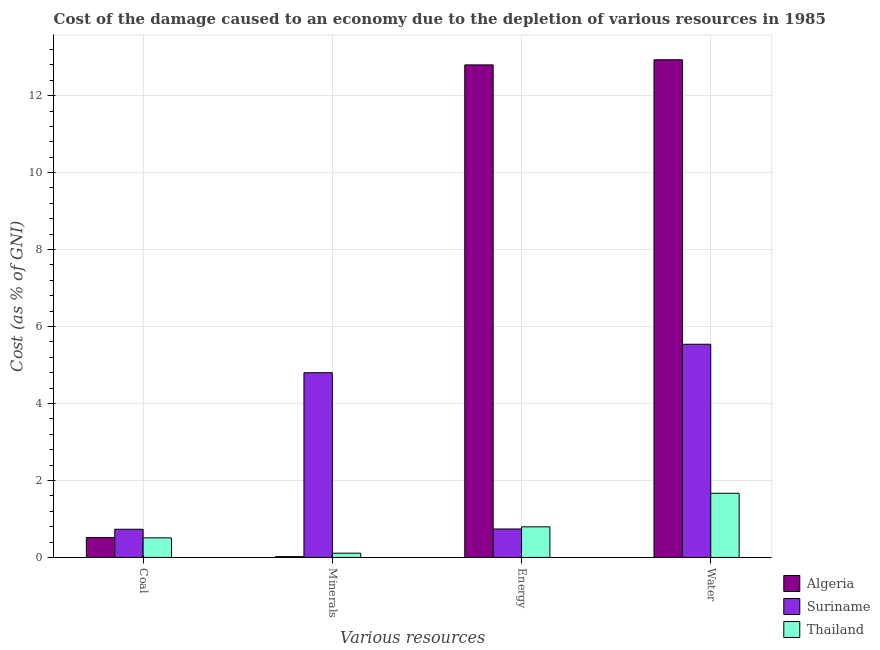How many different coloured bars are there?
Make the answer very short. 3. How many bars are there on the 4th tick from the left?
Your answer should be very brief. 3. How many bars are there on the 3rd tick from the right?
Your answer should be compact. 3. What is the label of the 3rd group of bars from the left?
Provide a short and direct response. Energy. What is the cost of damage due to depletion of water in Suriname?
Your answer should be compact. 5.54. Across all countries, what is the maximum cost of damage due to depletion of energy?
Make the answer very short. 12.8. Across all countries, what is the minimum cost of damage due to depletion of water?
Offer a terse response. 1.67. In which country was the cost of damage due to depletion of energy maximum?
Provide a succinct answer. Algeria. In which country was the cost of damage due to depletion of energy minimum?
Your response must be concise. Suriname. What is the total cost of damage due to depletion of minerals in the graph?
Your answer should be very brief. 4.93. What is the difference between the cost of damage due to depletion of minerals in Algeria and that in Thailand?
Make the answer very short. -0.09. What is the difference between the cost of damage due to depletion of minerals in Suriname and the cost of damage due to depletion of water in Thailand?
Your answer should be very brief. 3.13. What is the average cost of damage due to depletion of minerals per country?
Provide a short and direct response. 1.64. What is the difference between the cost of damage due to depletion of energy and cost of damage due to depletion of water in Algeria?
Offer a terse response. -0.13. What is the ratio of the cost of damage due to depletion of minerals in Algeria to that in Suriname?
Your response must be concise. 0. What is the difference between the highest and the second highest cost of damage due to depletion of coal?
Offer a very short reply. 0.22. What is the difference between the highest and the lowest cost of damage due to depletion of minerals?
Offer a very short reply. 4.78. What does the 3rd bar from the left in Water represents?
Keep it short and to the point. Thailand. What does the 1st bar from the right in Energy represents?
Give a very brief answer. Thailand. How many bars are there?
Your response must be concise. 12. Are all the bars in the graph horizontal?
Make the answer very short. No. How many countries are there in the graph?
Offer a terse response. 3. Are the values on the major ticks of Y-axis written in scientific E-notation?
Your response must be concise. No. How are the legend labels stacked?
Give a very brief answer. Vertical. What is the title of the graph?
Provide a short and direct response. Cost of the damage caused to an economy due to the depletion of various resources in 1985 . What is the label or title of the X-axis?
Offer a terse response. Various resources. What is the label or title of the Y-axis?
Provide a succinct answer. Cost (as % of GNI). What is the Cost (as % of GNI) in Algeria in Coal?
Provide a short and direct response. 0.52. What is the Cost (as % of GNI) of Suriname in Coal?
Your answer should be very brief. 0.73. What is the Cost (as % of GNI) in Thailand in Coal?
Give a very brief answer. 0.51. What is the Cost (as % of GNI) in Algeria in Minerals?
Your response must be concise. 0.02. What is the Cost (as % of GNI) in Suriname in Minerals?
Ensure brevity in your answer.  4.8. What is the Cost (as % of GNI) of Thailand in Minerals?
Provide a short and direct response. 0.11. What is the Cost (as % of GNI) of Algeria in Energy?
Provide a succinct answer. 12.8. What is the Cost (as % of GNI) in Suriname in Energy?
Provide a short and direct response. 0.74. What is the Cost (as % of GNI) in Thailand in Energy?
Your answer should be very brief. 0.8. What is the Cost (as % of GNI) of Algeria in Water?
Make the answer very short. 12.93. What is the Cost (as % of GNI) in Suriname in Water?
Make the answer very short. 5.54. What is the Cost (as % of GNI) in Thailand in Water?
Offer a terse response. 1.67. Across all Various resources, what is the maximum Cost (as % of GNI) of Algeria?
Provide a short and direct response. 12.93. Across all Various resources, what is the maximum Cost (as % of GNI) of Suriname?
Provide a succinct answer. 5.54. Across all Various resources, what is the maximum Cost (as % of GNI) of Thailand?
Offer a terse response. 1.67. Across all Various resources, what is the minimum Cost (as % of GNI) of Algeria?
Offer a very short reply. 0.02. Across all Various resources, what is the minimum Cost (as % of GNI) of Suriname?
Provide a succinct answer. 0.73. Across all Various resources, what is the minimum Cost (as % of GNI) in Thailand?
Provide a succinct answer. 0.11. What is the total Cost (as % of GNI) in Algeria in the graph?
Offer a very short reply. 26.27. What is the total Cost (as % of GNI) in Suriname in the graph?
Ensure brevity in your answer.  11.81. What is the total Cost (as % of GNI) of Thailand in the graph?
Provide a short and direct response. 3.08. What is the difference between the Cost (as % of GNI) in Algeria in Coal and that in Minerals?
Make the answer very short. 0.49. What is the difference between the Cost (as % of GNI) of Suriname in Coal and that in Minerals?
Ensure brevity in your answer.  -4.07. What is the difference between the Cost (as % of GNI) of Thailand in Coal and that in Minerals?
Make the answer very short. 0.4. What is the difference between the Cost (as % of GNI) of Algeria in Coal and that in Energy?
Provide a short and direct response. -12.28. What is the difference between the Cost (as % of GNI) in Suriname in Coal and that in Energy?
Your answer should be very brief. -0.01. What is the difference between the Cost (as % of GNI) in Thailand in Coal and that in Energy?
Give a very brief answer. -0.29. What is the difference between the Cost (as % of GNI) in Algeria in Coal and that in Water?
Keep it short and to the point. -12.42. What is the difference between the Cost (as % of GNI) of Suriname in Coal and that in Water?
Your answer should be compact. -4.81. What is the difference between the Cost (as % of GNI) of Thailand in Coal and that in Water?
Provide a succinct answer. -1.16. What is the difference between the Cost (as % of GNI) of Algeria in Minerals and that in Energy?
Offer a very short reply. -12.78. What is the difference between the Cost (as % of GNI) of Suriname in Minerals and that in Energy?
Offer a very short reply. 4.06. What is the difference between the Cost (as % of GNI) in Thailand in Minerals and that in Energy?
Provide a short and direct response. -0.69. What is the difference between the Cost (as % of GNI) in Algeria in Minerals and that in Water?
Give a very brief answer. -12.91. What is the difference between the Cost (as % of GNI) in Suriname in Minerals and that in Water?
Provide a short and direct response. -0.74. What is the difference between the Cost (as % of GNI) in Thailand in Minerals and that in Water?
Your response must be concise. -1.56. What is the difference between the Cost (as % of GNI) of Algeria in Energy and that in Water?
Offer a very short reply. -0.13. What is the difference between the Cost (as % of GNI) of Suriname in Energy and that in Water?
Ensure brevity in your answer.  -4.8. What is the difference between the Cost (as % of GNI) of Thailand in Energy and that in Water?
Provide a short and direct response. -0.87. What is the difference between the Cost (as % of GNI) of Algeria in Coal and the Cost (as % of GNI) of Suriname in Minerals?
Provide a short and direct response. -4.28. What is the difference between the Cost (as % of GNI) of Algeria in Coal and the Cost (as % of GNI) of Thailand in Minerals?
Provide a short and direct response. 0.41. What is the difference between the Cost (as % of GNI) of Suriname in Coal and the Cost (as % of GNI) of Thailand in Minerals?
Your answer should be compact. 0.62. What is the difference between the Cost (as % of GNI) in Algeria in Coal and the Cost (as % of GNI) in Suriname in Energy?
Keep it short and to the point. -0.22. What is the difference between the Cost (as % of GNI) of Algeria in Coal and the Cost (as % of GNI) of Thailand in Energy?
Offer a terse response. -0.28. What is the difference between the Cost (as % of GNI) in Suriname in Coal and the Cost (as % of GNI) in Thailand in Energy?
Offer a very short reply. -0.06. What is the difference between the Cost (as % of GNI) of Algeria in Coal and the Cost (as % of GNI) of Suriname in Water?
Provide a succinct answer. -5.02. What is the difference between the Cost (as % of GNI) of Algeria in Coal and the Cost (as % of GNI) of Thailand in Water?
Offer a terse response. -1.15. What is the difference between the Cost (as % of GNI) in Suriname in Coal and the Cost (as % of GNI) in Thailand in Water?
Provide a succinct answer. -0.94. What is the difference between the Cost (as % of GNI) in Algeria in Minerals and the Cost (as % of GNI) in Suriname in Energy?
Offer a very short reply. -0.72. What is the difference between the Cost (as % of GNI) of Algeria in Minerals and the Cost (as % of GNI) of Thailand in Energy?
Give a very brief answer. -0.77. What is the difference between the Cost (as % of GNI) of Suriname in Minerals and the Cost (as % of GNI) of Thailand in Energy?
Offer a terse response. 4. What is the difference between the Cost (as % of GNI) of Algeria in Minerals and the Cost (as % of GNI) of Suriname in Water?
Your answer should be very brief. -5.52. What is the difference between the Cost (as % of GNI) of Algeria in Minerals and the Cost (as % of GNI) of Thailand in Water?
Make the answer very short. -1.65. What is the difference between the Cost (as % of GNI) in Suriname in Minerals and the Cost (as % of GNI) in Thailand in Water?
Your response must be concise. 3.13. What is the difference between the Cost (as % of GNI) of Algeria in Energy and the Cost (as % of GNI) of Suriname in Water?
Offer a very short reply. 7.26. What is the difference between the Cost (as % of GNI) of Algeria in Energy and the Cost (as % of GNI) of Thailand in Water?
Offer a terse response. 11.13. What is the difference between the Cost (as % of GNI) of Suriname in Energy and the Cost (as % of GNI) of Thailand in Water?
Offer a very short reply. -0.93. What is the average Cost (as % of GNI) of Algeria per Various resources?
Offer a very short reply. 6.57. What is the average Cost (as % of GNI) of Suriname per Various resources?
Provide a short and direct response. 2.95. What is the average Cost (as % of GNI) of Thailand per Various resources?
Your response must be concise. 0.77. What is the difference between the Cost (as % of GNI) in Algeria and Cost (as % of GNI) in Suriname in Coal?
Offer a very short reply. -0.22. What is the difference between the Cost (as % of GNI) in Algeria and Cost (as % of GNI) in Thailand in Coal?
Your answer should be very brief. 0.01. What is the difference between the Cost (as % of GNI) in Suriname and Cost (as % of GNI) in Thailand in Coal?
Your answer should be very brief. 0.22. What is the difference between the Cost (as % of GNI) in Algeria and Cost (as % of GNI) in Suriname in Minerals?
Give a very brief answer. -4.78. What is the difference between the Cost (as % of GNI) of Algeria and Cost (as % of GNI) of Thailand in Minerals?
Keep it short and to the point. -0.09. What is the difference between the Cost (as % of GNI) of Suriname and Cost (as % of GNI) of Thailand in Minerals?
Give a very brief answer. 4.69. What is the difference between the Cost (as % of GNI) in Algeria and Cost (as % of GNI) in Suriname in Energy?
Keep it short and to the point. 12.06. What is the difference between the Cost (as % of GNI) in Algeria and Cost (as % of GNI) in Thailand in Energy?
Provide a short and direct response. 12. What is the difference between the Cost (as % of GNI) of Suriname and Cost (as % of GNI) of Thailand in Energy?
Keep it short and to the point. -0.06. What is the difference between the Cost (as % of GNI) in Algeria and Cost (as % of GNI) in Suriname in Water?
Give a very brief answer. 7.39. What is the difference between the Cost (as % of GNI) of Algeria and Cost (as % of GNI) of Thailand in Water?
Ensure brevity in your answer.  11.26. What is the difference between the Cost (as % of GNI) of Suriname and Cost (as % of GNI) of Thailand in Water?
Ensure brevity in your answer.  3.87. What is the ratio of the Cost (as % of GNI) in Algeria in Coal to that in Minerals?
Provide a short and direct response. 24.28. What is the ratio of the Cost (as % of GNI) in Suriname in Coal to that in Minerals?
Provide a succinct answer. 0.15. What is the ratio of the Cost (as % of GNI) in Thailand in Coal to that in Minerals?
Offer a terse response. 4.61. What is the ratio of the Cost (as % of GNI) of Algeria in Coal to that in Energy?
Provide a succinct answer. 0.04. What is the ratio of the Cost (as % of GNI) of Thailand in Coal to that in Energy?
Your answer should be very brief. 0.64. What is the ratio of the Cost (as % of GNI) in Algeria in Coal to that in Water?
Your response must be concise. 0.04. What is the ratio of the Cost (as % of GNI) of Suriname in Coal to that in Water?
Offer a terse response. 0.13. What is the ratio of the Cost (as % of GNI) in Thailand in Coal to that in Water?
Make the answer very short. 0.3. What is the ratio of the Cost (as % of GNI) in Algeria in Minerals to that in Energy?
Offer a terse response. 0. What is the ratio of the Cost (as % of GNI) in Suriname in Minerals to that in Energy?
Provide a short and direct response. 6.49. What is the ratio of the Cost (as % of GNI) of Thailand in Minerals to that in Energy?
Make the answer very short. 0.14. What is the ratio of the Cost (as % of GNI) of Algeria in Minerals to that in Water?
Provide a short and direct response. 0. What is the ratio of the Cost (as % of GNI) in Suriname in Minerals to that in Water?
Ensure brevity in your answer.  0.87. What is the ratio of the Cost (as % of GNI) of Thailand in Minerals to that in Water?
Your answer should be very brief. 0.07. What is the ratio of the Cost (as % of GNI) of Suriname in Energy to that in Water?
Provide a short and direct response. 0.13. What is the ratio of the Cost (as % of GNI) of Thailand in Energy to that in Water?
Your response must be concise. 0.48. What is the difference between the highest and the second highest Cost (as % of GNI) of Algeria?
Offer a terse response. 0.13. What is the difference between the highest and the second highest Cost (as % of GNI) of Suriname?
Offer a terse response. 0.74. What is the difference between the highest and the second highest Cost (as % of GNI) of Thailand?
Provide a succinct answer. 0.87. What is the difference between the highest and the lowest Cost (as % of GNI) of Algeria?
Your answer should be very brief. 12.91. What is the difference between the highest and the lowest Cost (as % of GNI) of Suriname?
Your response must be concise. 4.81. What is the difference between the highest and the lowest Cost (as % of GNI) of Thailand?
Your response must be concise. 1.56. 